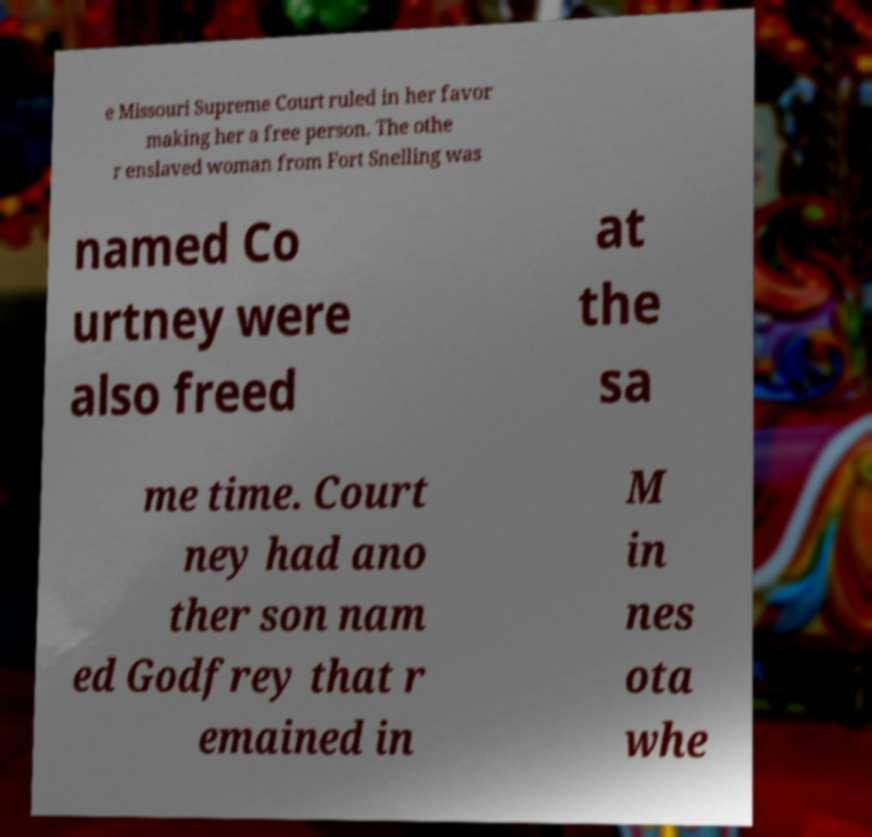Could you extract and type out the text from this image? e Missouri Supreme Court ruled in her favor making her a free person. The othe r enslaved woman from Fort Snelling was named Co urtney were also freed at the sa me time. Court ney had ano ther son nam ed Godfrey that r emained in M in nes ota whe 